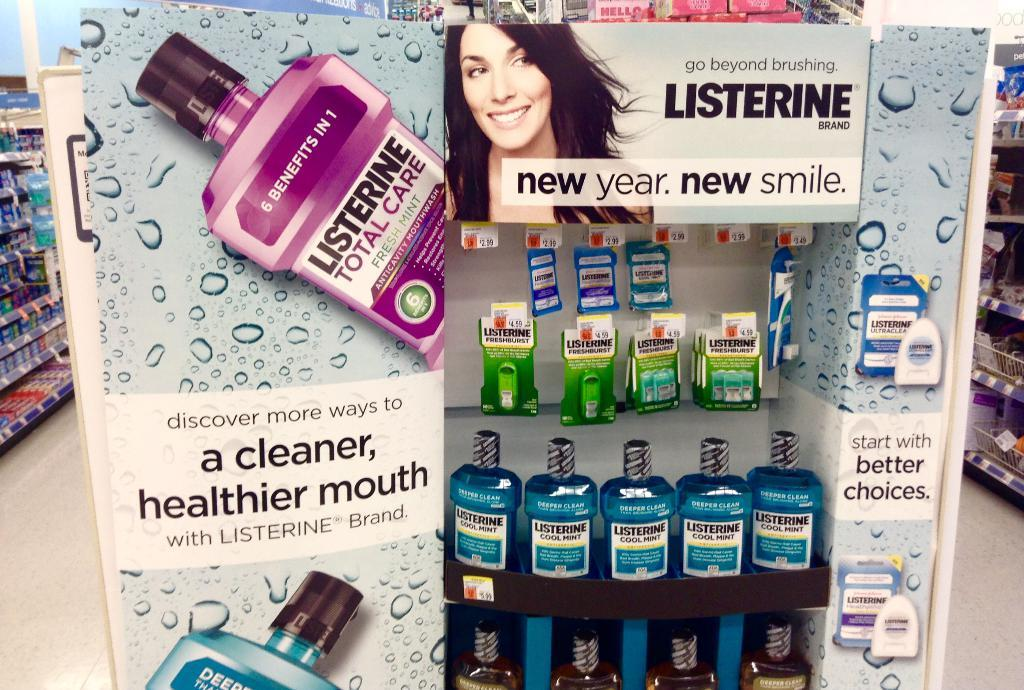<image>
Offer a succinct explanation of the picture presented. A big bottle of Listerine, on display, cost $5.99. 